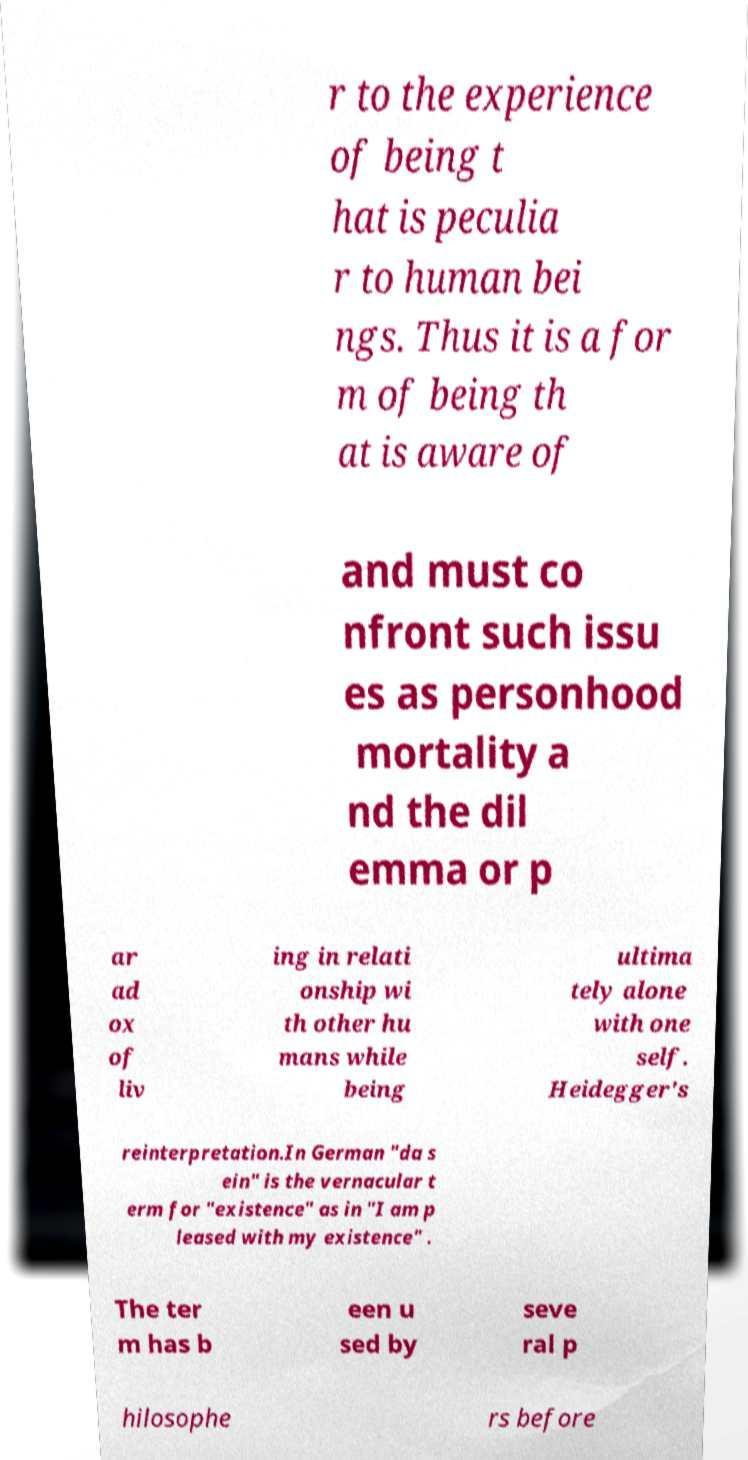What messages or text are displayed in this image? I need them in a readable, typed format. r to the experience of being t hat is peculia r to human bei ngs. Thus it is a for m of being th at is aware of and must co nfront such issu es as personhood mortality a nd the dil emma or p ar ad ox of liv ing in relati onship wi th other hu mans while being ultima tely alone with one self. Heidegger's reinterpretation.In German "da s ein" is the vernacular t erm for "existence" as in "I am p leased with my existence" . The ter m has b een u sed by seve ral p hilosophe rs before 